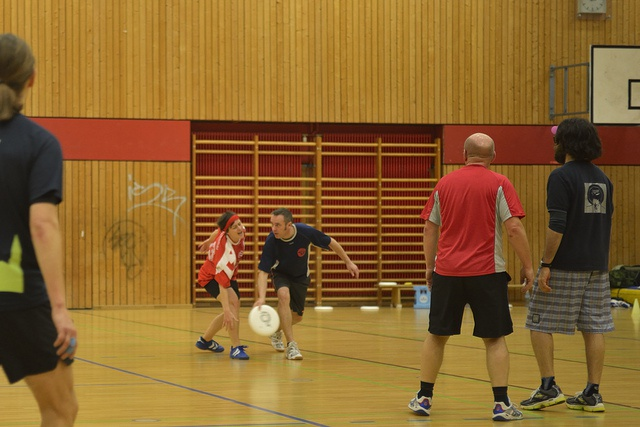Describe the objects in this image and their specific colors. I can see people in orange, brown, black, olive, and maroon tones, people in orange, black, olive, and tan tones, people in orange, black, olive, gray, and maroon tones, people in orange, black, olive, and tan tones, and people in orange, brown, black, and tan tones in this image. 